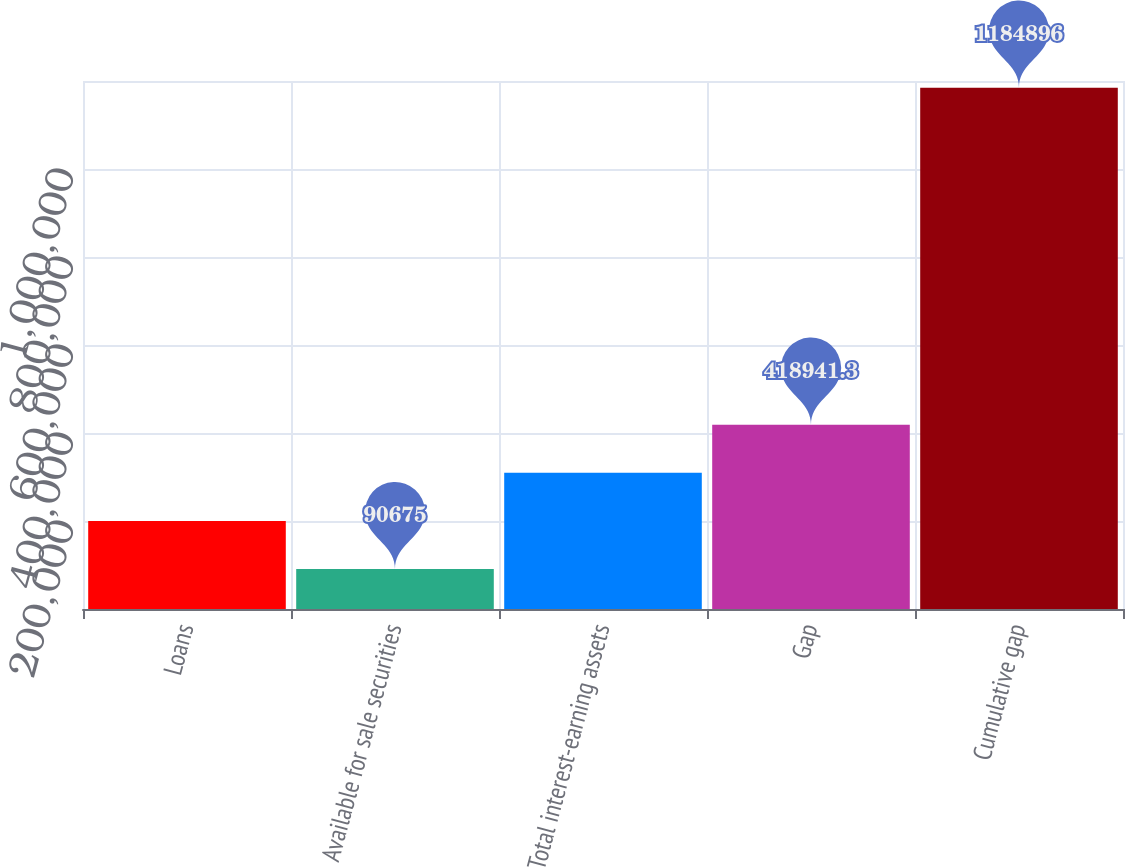Convert chart. <chart><loc_0><loc_0><loc_500><loc_500><bar_chart><fcel>Loans<fcel>Available for sale securities<fcel>Total interest-earning assets<fcel>Gap<fcel>Cumulative gap<nl><fcel>200097<fcel>90675<fcel>309519<fcel>418941<fcel>1.1849e+06<nl></chart> 